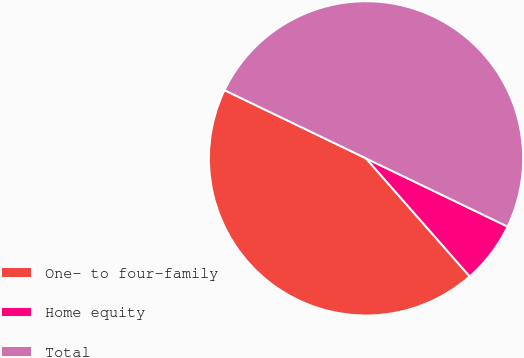<chart> <loc_0><loc_0><loc_500><loc_500><pie_chart><fcel>One- to four-family<fcel>Home equity<fcel>Total<nl><fcel>43.62%<fcel>6.38%<fcel>50.0%<nl></chart> 